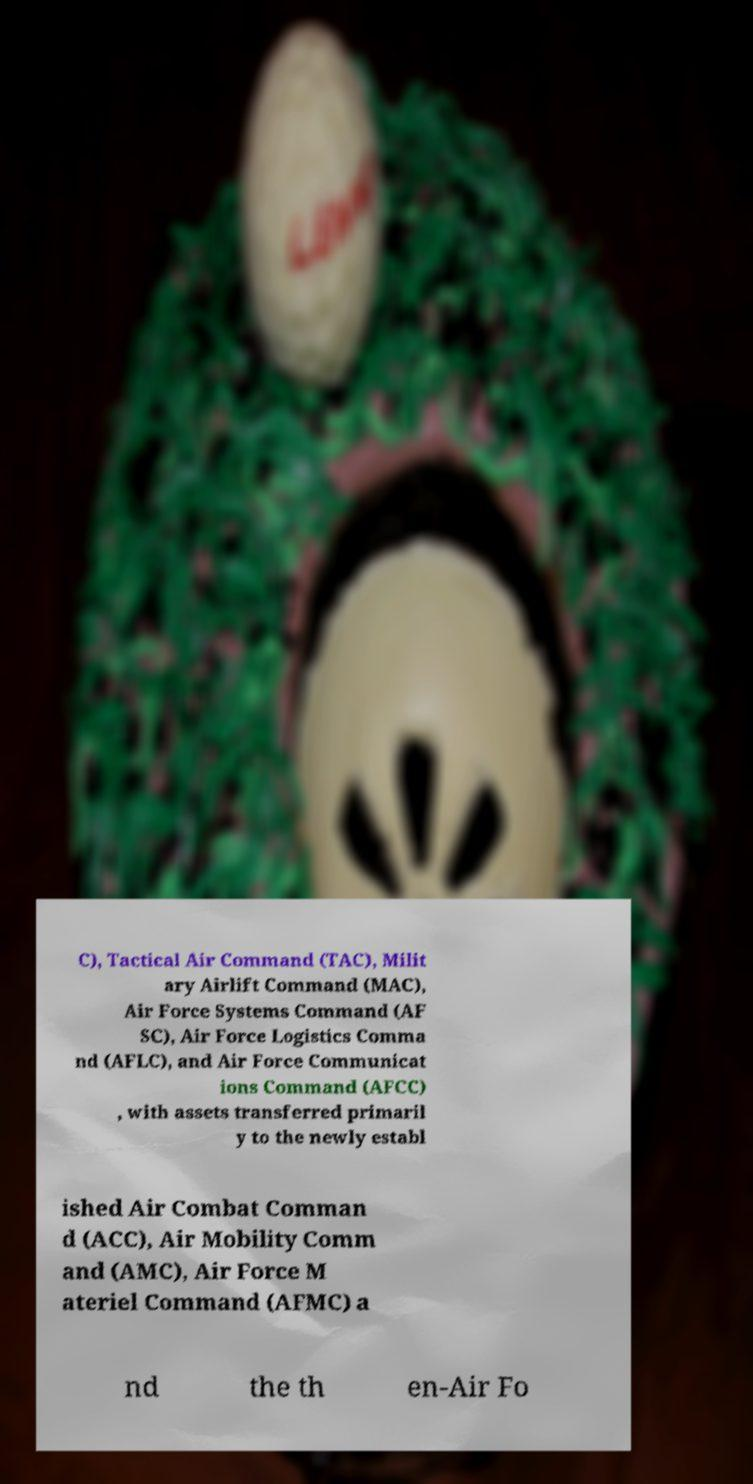I need the written content from this picture converted into text. Can you do that? C), Tactical Air Command (TAC), Milit ary Airlift Command (MAC), Air Force Systems Command (AF SC), Air Force Logistics Comma nd (AFLC), and Air Force Communicat ions Command (AFCC) , with assets transferred primaril y to the newly establ ished Air Combat Comman d (ACC), Air Mobility Comm and (AMC), Air Force M ateriel Command (AFMC) a nd the th en-Air Fo 